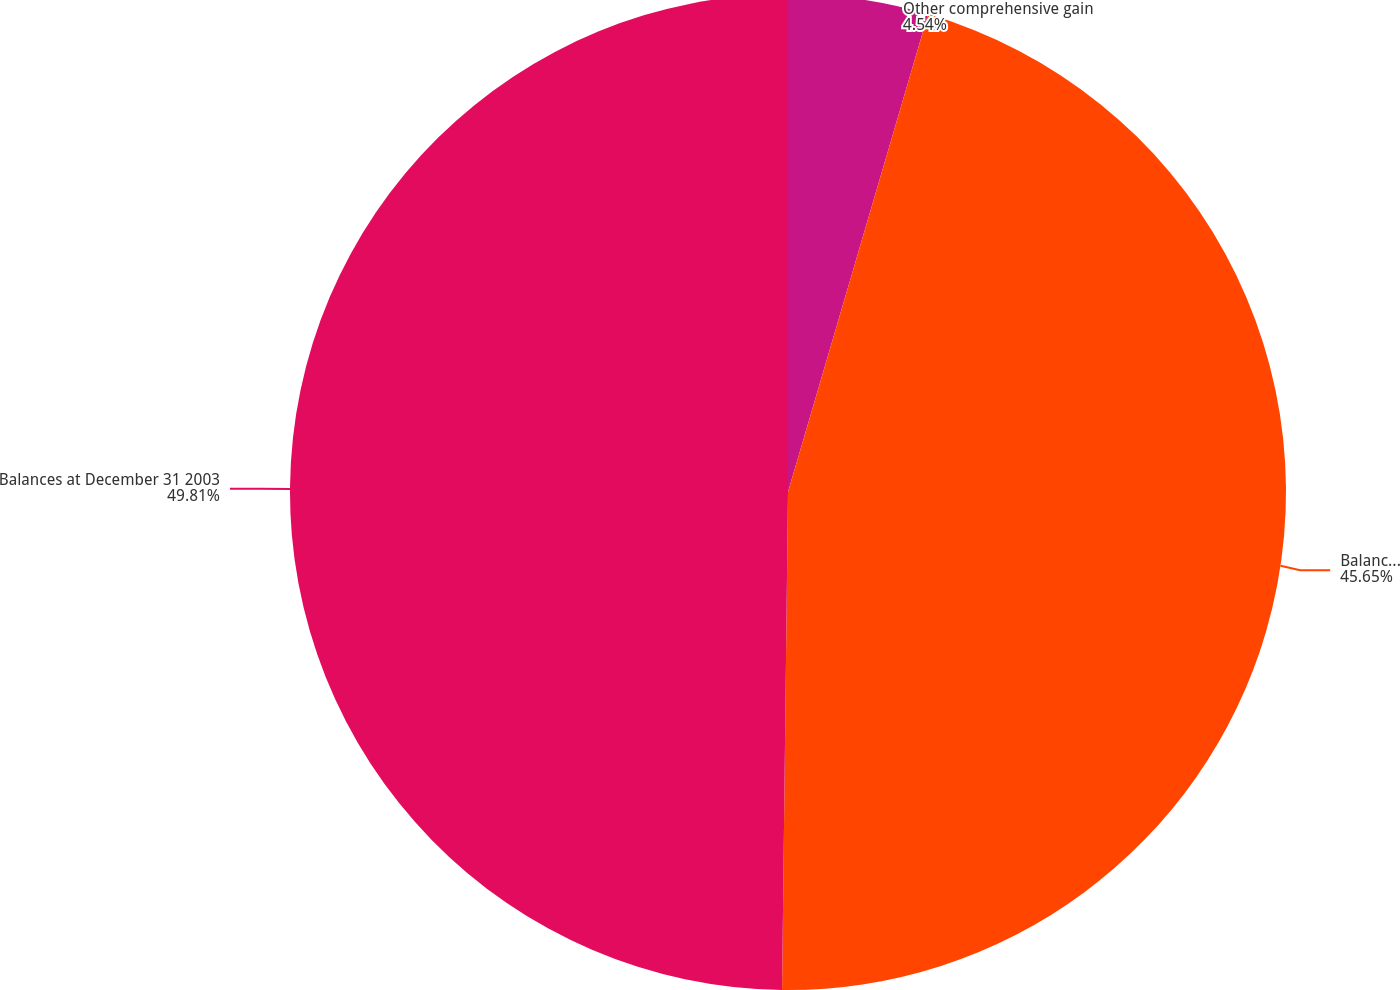Convert chart to OTSL. <chart><loc_0><loc_0><loc_500><loc_500><pie_chart><fcel>Other comprehensive gain<fcel>Balances at December 31 2002<fcel>Balances at December 31 2003<nl><fcel>4.54%<fcel>45.65%<fcel>49.81%<nl></chart> 